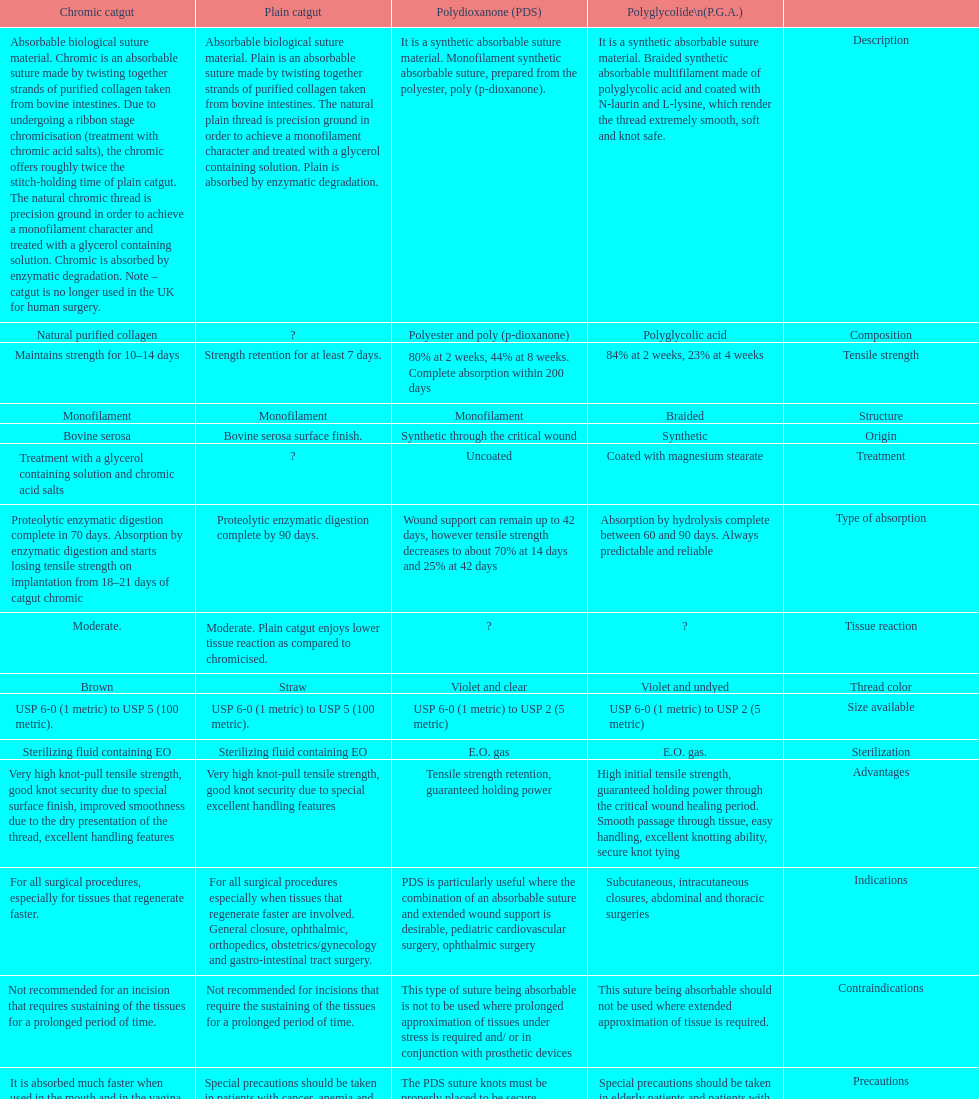Plain catgut and chromic catgut both have what type of structure? Monofilament. 